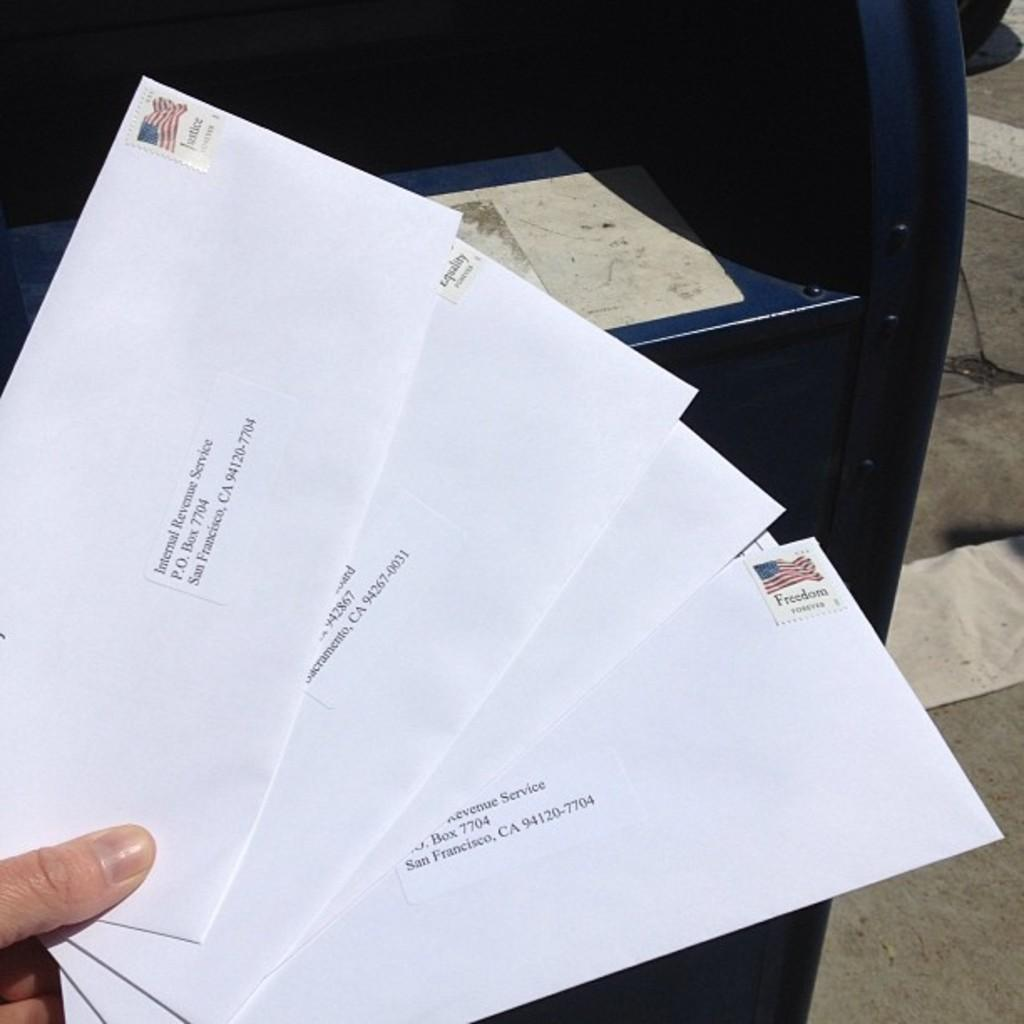<image>
Relay a brief, clear account of the picture shown. many envelopes addressed to the Internal Revenue Service in San Francisco 